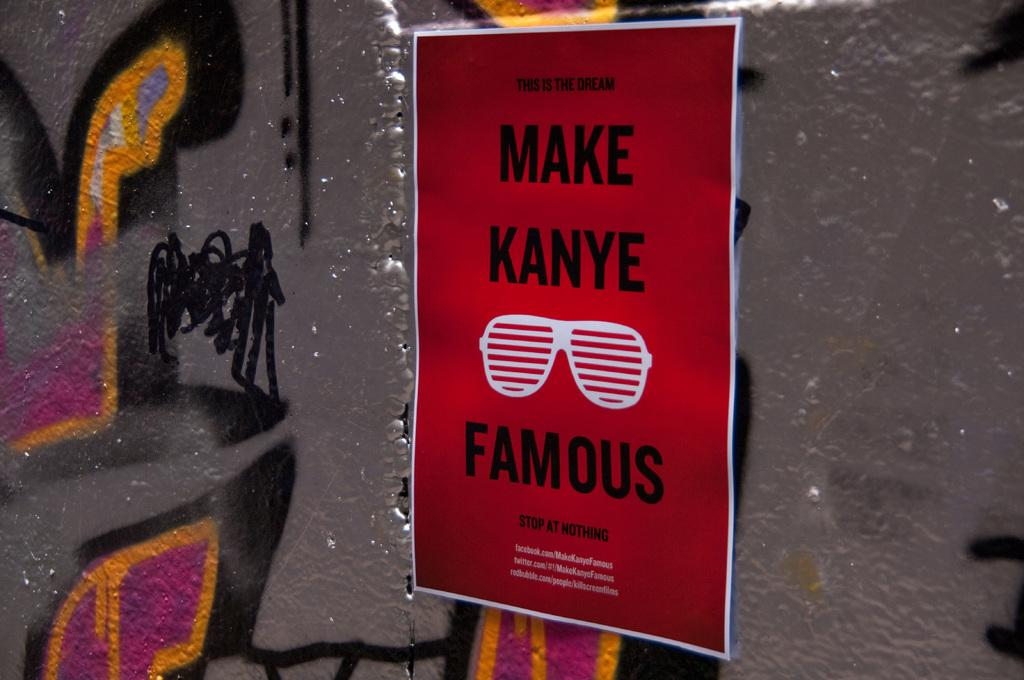<image>
Render a clear and concise summary of the photo. A poster for Make Kanye Famous on a grey wall. 